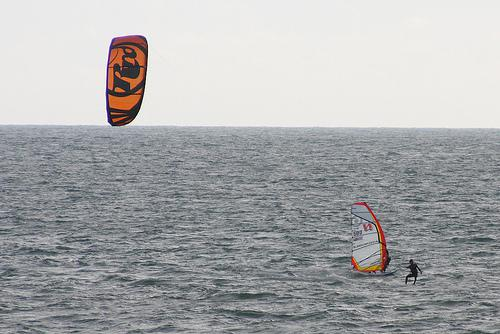Question: where is this photo taken?
Choices:
A. The ocean.
B. The forest.
C. The lake.
D. The river.
Answer with the letter. Answer: A Question: who is windsurfing?
Choices:
A. The girl with braids.
B. The boy in the wetsuit.
C. The lady in the bikini.
D. The guy in black.
Answer with the letter. Answer: D Question: what kind of day is it in the photo?
Choices:
A. Cloudy.
B. Sunny.
C. Rainy.
D. Snowy.
Answer with the letter. Answer: A Question: what color is the water?
Choices:
A. Green.
B. Blue.
C. White.
D. Gray.
Answer with the letter. Answer: D 